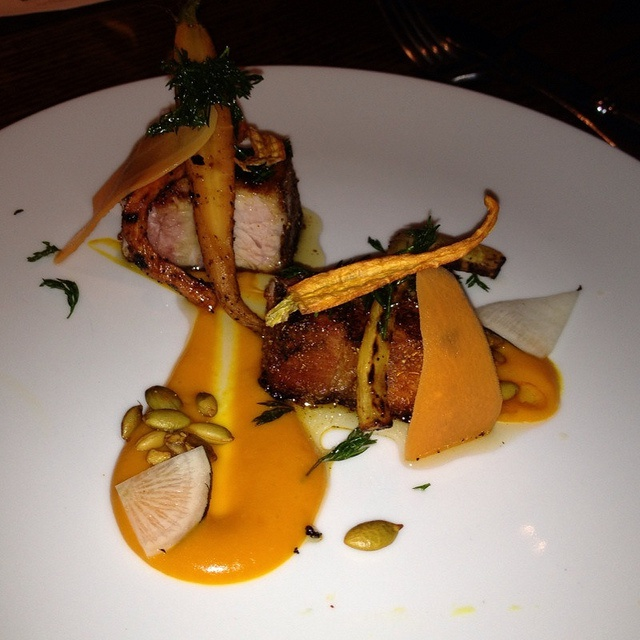Describe the objects in this image and their specific colors. I can see dining table in maroon, black, and gray tones, carrot in maroon, red, and orange tones, carrot in maroon, brown, and black tones, fork in maroon, black, gray, and brown tones, and knife in maroon, black, gray, and brown tones in this image. 